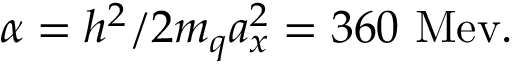<formula> <loc_0><loc_0><loc_500><loc_500>\alpha = h ^ { 2 } / 2 m _ { q } a _ { x } ^ { 2 } = 3 6 0 M e v .</formula> 